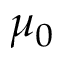Convert formula to latex. <formula><loc_0><loc_0><loc_500><loc_500>\mu _ { 0 }</formula> 